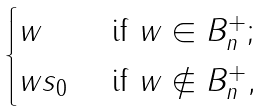<formula> <loc_0><loc_0><loc_500><loc_500>\begin{cases} w & \text { if } w \in B _ { n } ^ { + } ; \\ w s _ { 0 } & \text { if } w \not \in B _ { n } ^ { + } , \end{cases}</formula> 